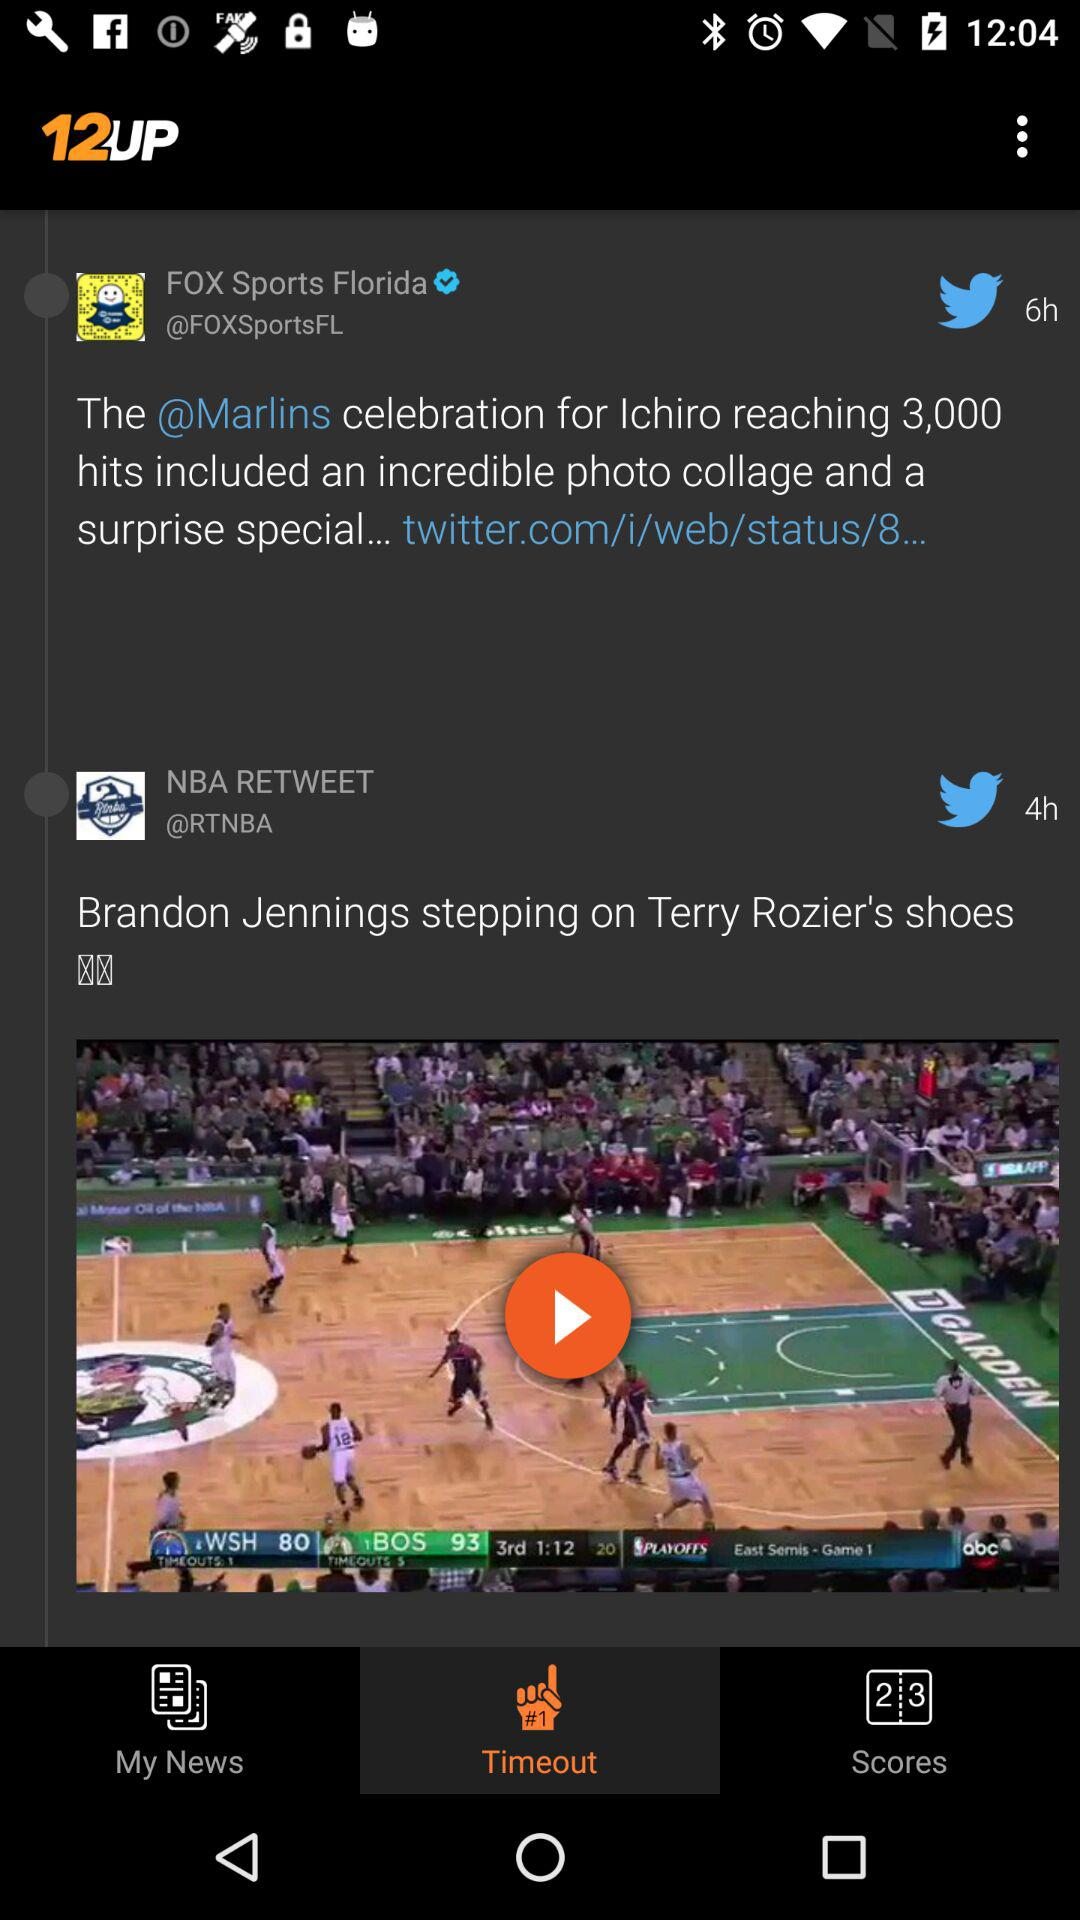How many hours ago was "FOX Sports Florida" tweeted? "FOX Sports Florida" was tweeted 6 hours ago. 